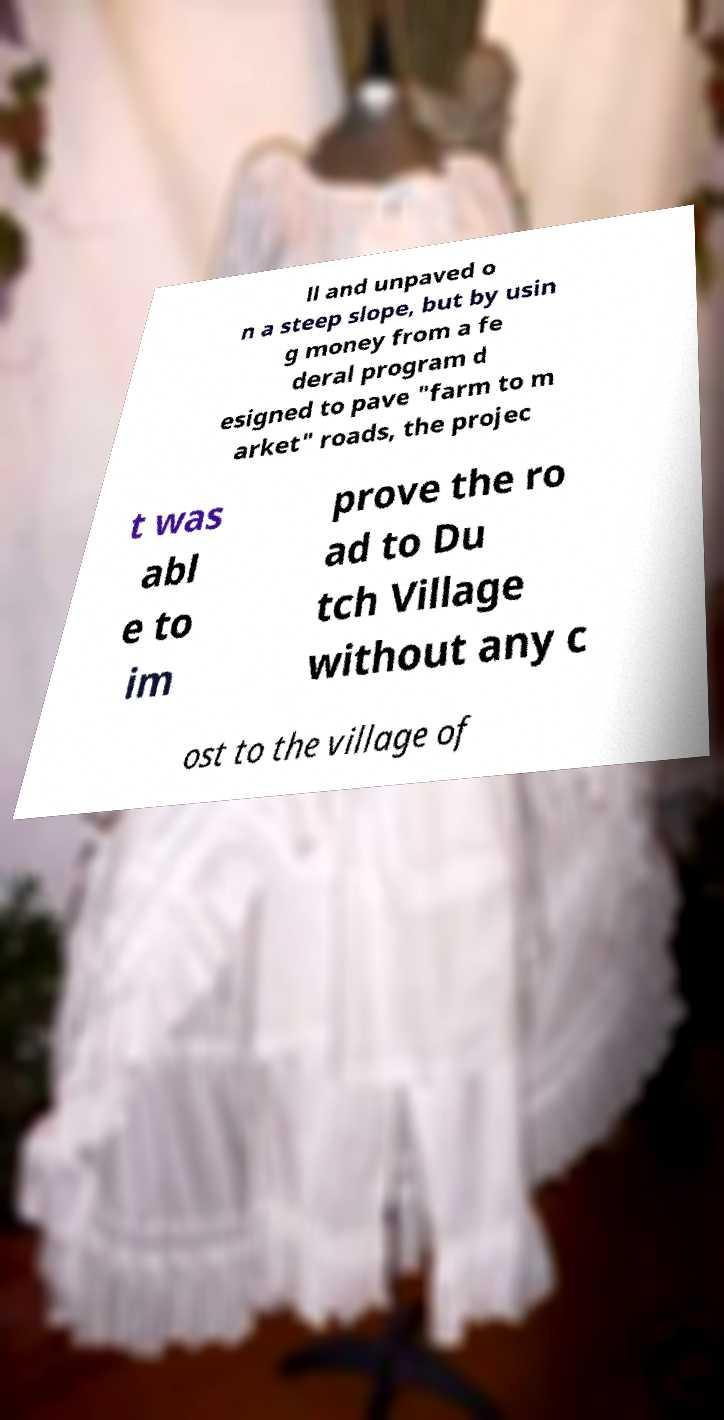What messages or text are displayed in this image? I need them in a readable, typed format. ll and unpaved o n a steep slope, but by usin g money from a fe deral program d esigned to pave "farm to m arket" roads, the projec t was abl e to im prove the ro ad to Du tch Village without any c ost to the village of 